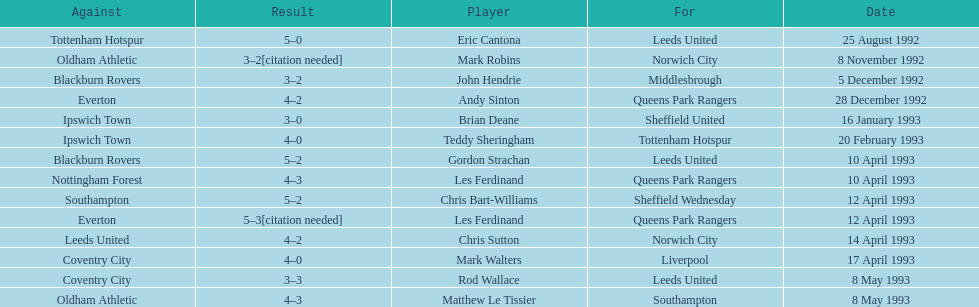In the 1992-1993 premier league, what was the total number of hat tricks scored by all players? 14. Could you help me parse every detail presented in this table? {'header': ['Against', 'Result', 'Player', 'For', 'Date'], 'rows': [['Tottenham Hotspur', '5–0', 'Eric Cantona', 'Leeds United', '25 August 1992'], ['Oldham Athletic', '3–2[citation needed]', 'Mark Robins', 'Norwich City', '8 November 1992'], ['Blackburn Rovers', '3–2', 'John Hendrie', 'Middlesbrough', '5 December 1992'], ['Everton', '4–2', 'Andy Sinton', 'Queens Park Rangers', '28 December 1992'], ['Ipswich Town', '3–0', 'Brian Deane', 'Sheffield United', '16 January 1993'], ['Ipswich Town', '4–0', 'Teddy Sheringham', 'Tottenham Hotspur', '20 February 1993'], ['Blackburn Rovers', '5–2', 'Gordon Strachan', 'Leeds United', '10 April 1993'], ['Nottingham Forest', '4–3', 'Les Ferdinand', 'Queens Park Rangers', '10 April 1993'], ['Southampton', '5–2', 'Chris Bart-Williams', 'Sheffield Wednesday', '12 April 1993'], ['Everton', '5–3[citation needed]', 'Les Ferdinand', 'Queens Park Rangers', '12 April 1993'], ['Leeds United', '4–2', 'Chris Sutton', 'Norwich City', '14 April 1993'], ['Coventry City', '4–0', 'Mark Walters', 'Liverpool', '17 April 1993'], ['Coventry City', '3–3', 'Rod Wallace', 'Leeds United', '8 May 1993'], ['Oldham Athletic', '4–3', 'Matthew Le Tissier', 'Southampton', '8 May 1993']]} 